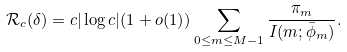<formula> <loc_0><loc_0><loc_500><loc_500>\mathcal { R } _ { c } ( \delta ) = c | \log c | ( 1 + o ( 1 ) ) \sum _ { 0 \leq m \leq M - 1 } \frac { \pi _ { m } } { I ( m ; \bar { \phi } _ { m } ) } .</formula> 